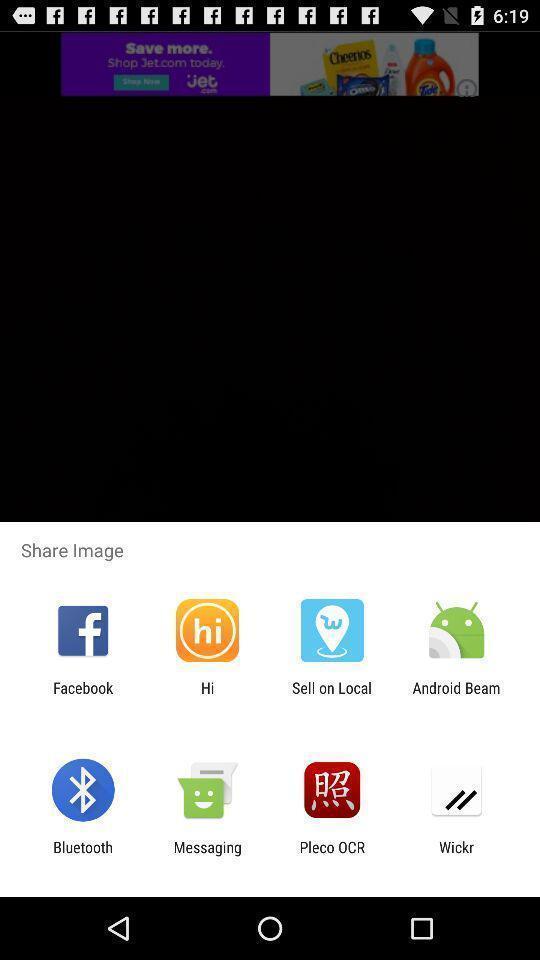Explain what's happening in this screen capture. Screen showing various applications to share. 